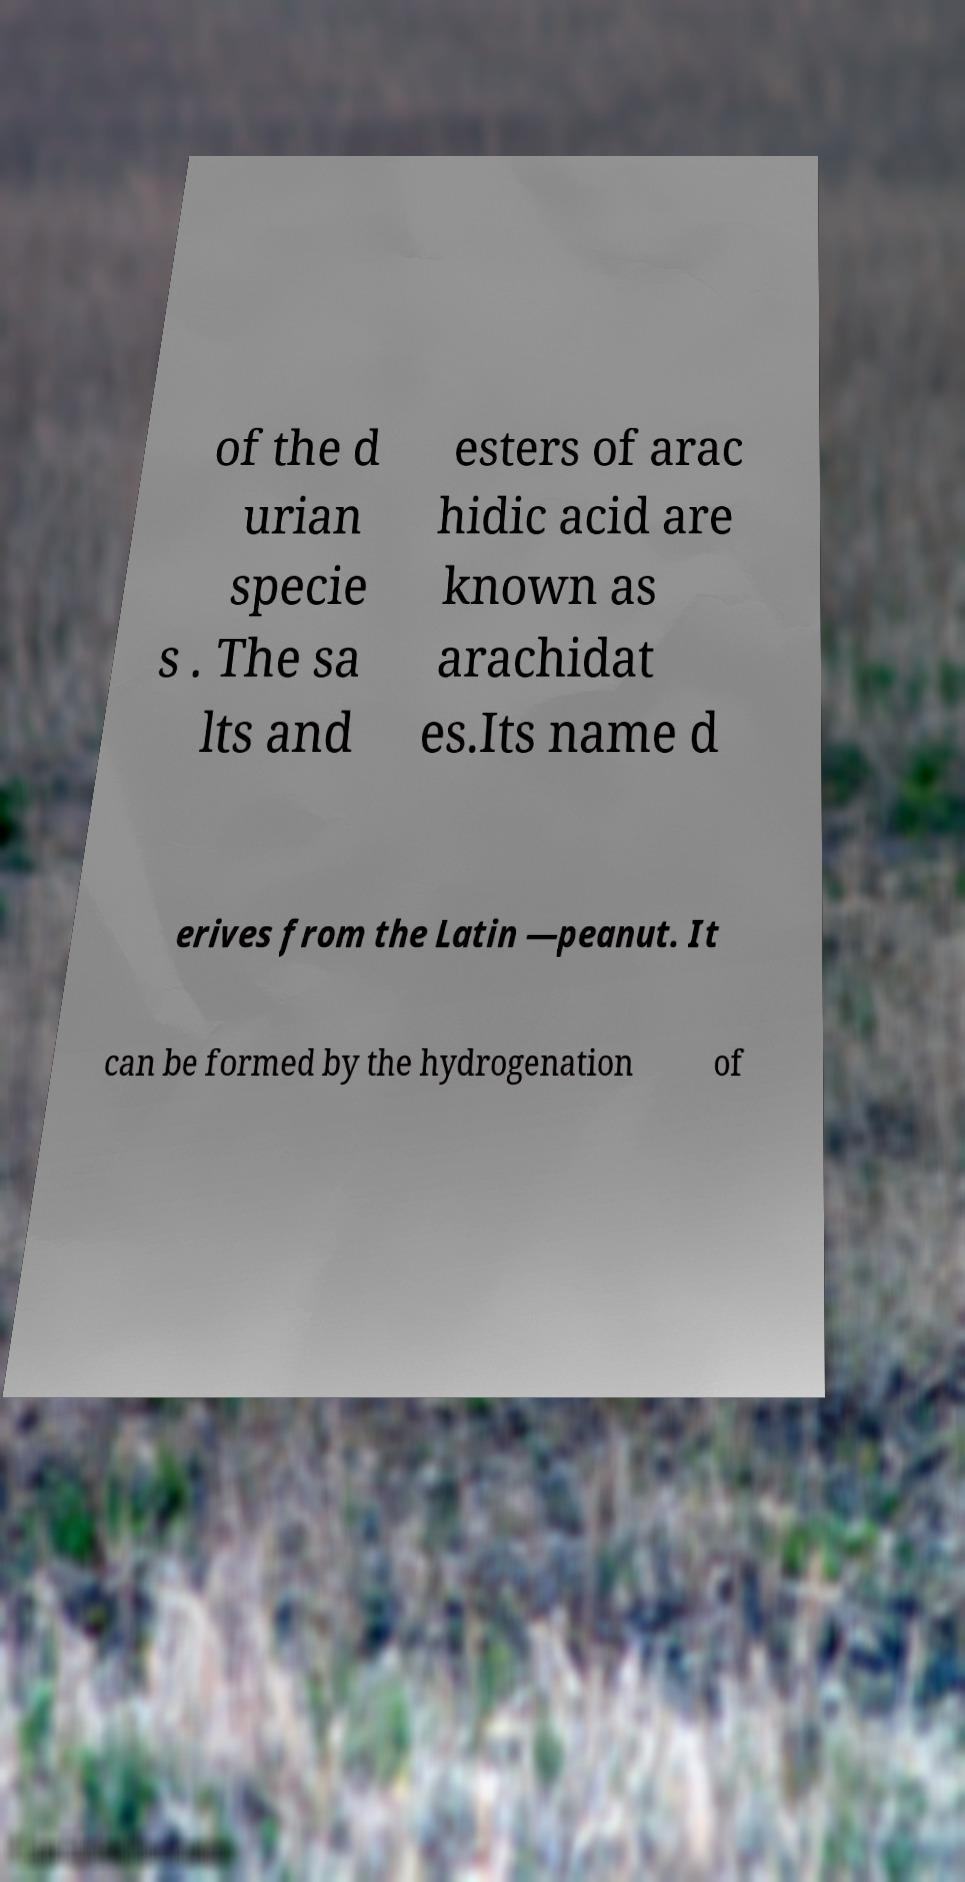I need the written content from this picture converted into text. Can you do that? of the d urian specie s . The sa lts and esters of arac hidic acid are known as arachidat es.Its name d erives from the Latin —peanut. It can be formed by the hydrogenation of 